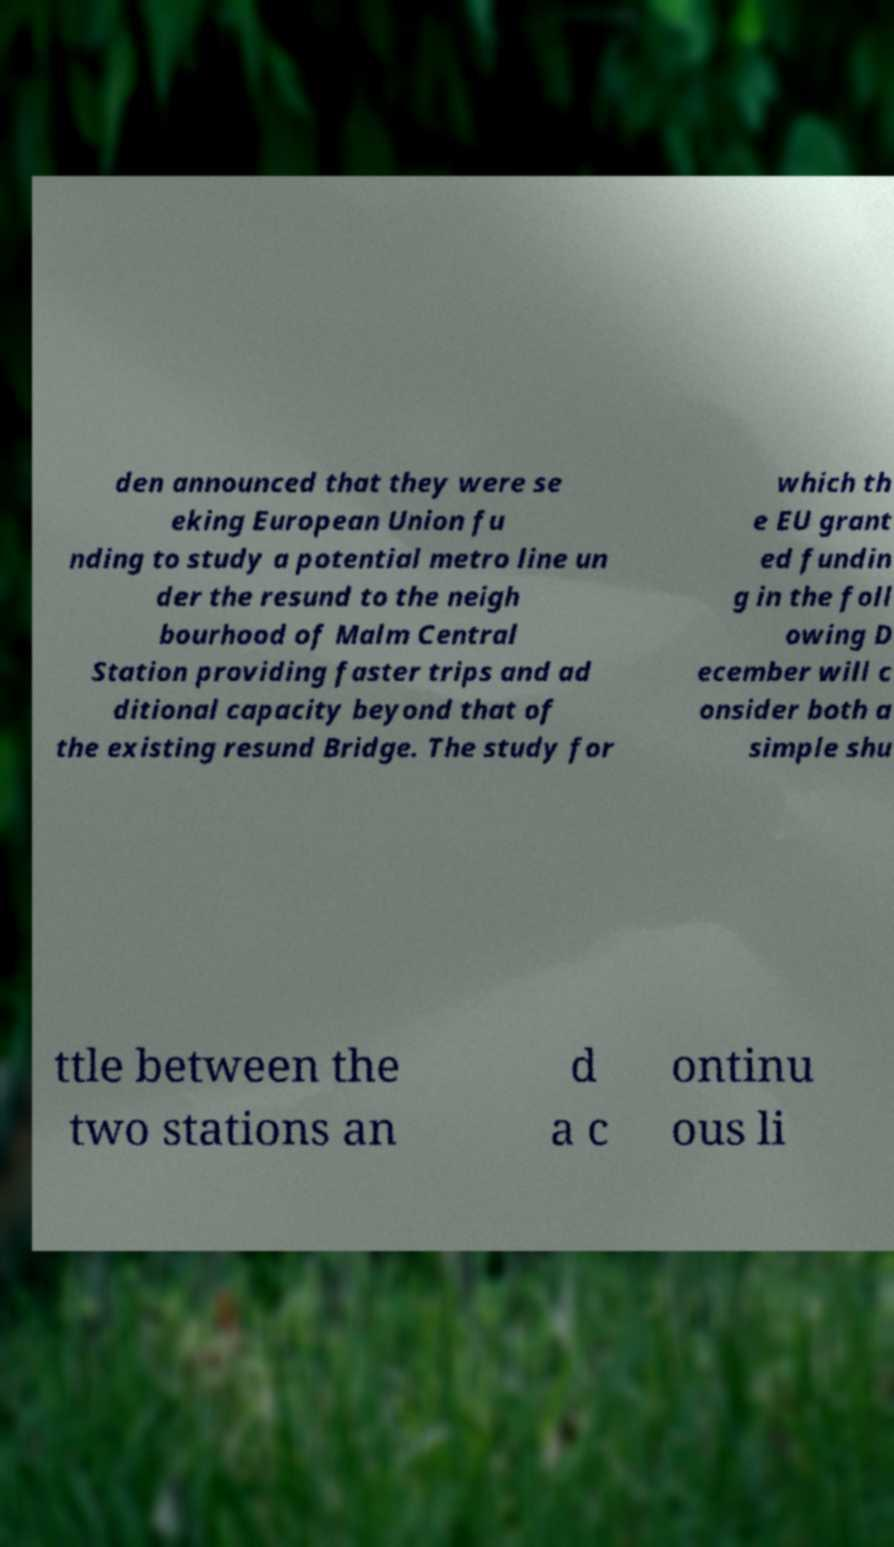What messages or text are displayed in this image? I need them in a readable, typed format. den announced that they were se eking European Union fu nding to study a potential metro line un der the resund to the neigh bourhood of Malm Central Station providing faster trips and ad ditional capacity beyond that of the existing resund Bridge. The study for which th e EU grant ed fundin g in the foll owing D ecember will c onsider both a simple shu ttle between the two stations an d a c ontinu ous li 